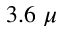<formula> <loc_0><loc_0><loc_500><loc_500>3 . 6 \mu</formula> 